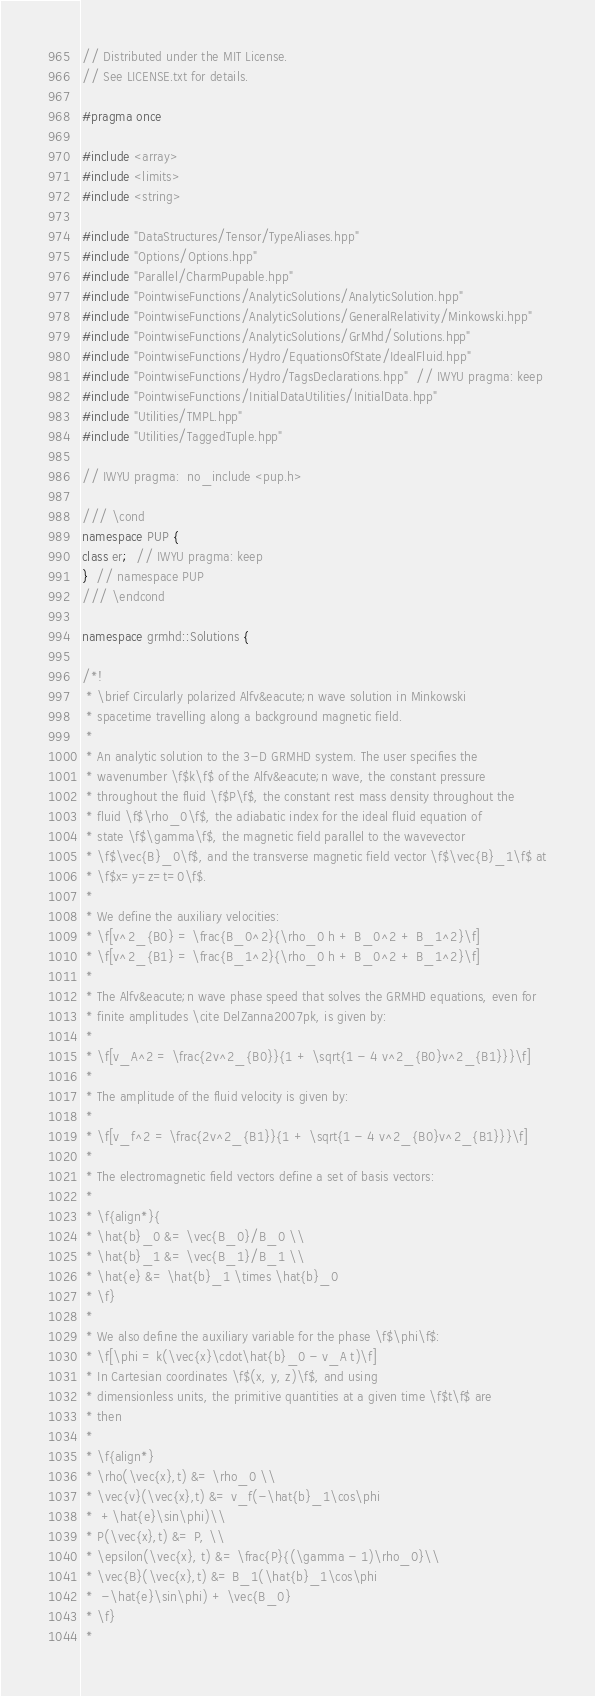Convert code to text. <code><loc_0><loc_0><loc_500><loc_500><_C++_>// Distributed under the MIT License.
// See LICENSE.txt for details.

#pragma once

#include <array>
#include <limits>
#include <string>

#include "DataStructures/Tensor/TypeAliases.hpp"
#include "Options/Options.hpp"
#include "Parallel/CharmPupable.hpp"
#include "PointwiseFunctions/AnalyticSolutions/AnalyticSolution.hpp"
#include "PointwiseFunctions/AnalyticSolutions/GeneralRelativity/Minkowski.hpp"
#include "PointwiseFunctions/AnalyticSolutions/GrMhd/Solutions.hpp"
#include "PointwiseFunctions/Hydro/EquationsOfState/IdealFluid.hpp"
#include "PointwiseFunctions/Hydro/TagsDeclarations.hpp"  // IWYU pragma: keep
#include "PointwiseFunctions/InitialDataUtilities/InitialData.hpp"
#include "Utilities/TMPL.hpp"
#include "Utilities/TaggedTuple.hpp"

// IWYU pragma:  no_include <pup.h>

/// \cond
namespace PUP {
class er;  // IWYU pragma: keep
}  // namespace PUP
/// \endcond

namespace grmhd::Solutions {

/*!
 * \brief Circularly polarized Alfv&eacute;n wave solution in Minkowski
 * spacetime travelling along a background magnetic field.
 *
 * An analytic solution to the 3-D GRMHD system. The user specifies the
 * wavenumber \f$k\f$ of the Alfv&eacute;n wave, the constant pressure
 * throughout the fluid \f$P\f$, the constant rest mass density throughout the
 * fluid \f$\rho_0\f$, the adiabatic index for the ideal fluid equation of
 * state \f$\gamma\f$, the magnetic field parallel to the wavevector
 * \f$\vec{B}_0\f$, and the transverse magnetic field vector \f$\vec{B}_1\f$ at
 * \f$x=y=z=t=0\f$.
 *
 * We define the auxiliary velocities:
 * \f[v^2_{B0} = \frac{B_0^2}{\rho_0 h + B_0^2 + B_1^2}\f]
 * \f[v^2_{B1} = \frac{B_1^2}{\rho_0 h + B_0^2 + B_1^2}\f]
 *
 * The Alfv&eacute;n wave phase speed that solves the GRMHD equations, even for
 * finite amplitudes \cite DelZanna2007pk, is given by:
 *
 * \f[v_A^2 = \frac{2v^2_{B0}}{1 + \sqrt{1 - 4 v^2_{B0}v^2_{B1}}}\f]
 *
 * The amplitude of the fluid velocity is given by:
 *
 * \f[v_f^2 = \frac{2v^2_{B1}}{1 + \sqrt{1 - 4 v^2_{B0}v^2_{B1}}}\f]
 *
 * The electromagnetic field vectors define a set of basis vectors:
 *
 * \f{align*}{
 * \hat{b}_0 &= \vec{B_0}/B_0 \\
 * \hat{b}_1 &= \vec{B_1}/B_1 \\
 * \hat{e} &= \hat{b}_1 \times \hat{b}_0
 * \f}
 *
 * We also define the auxiliary variable for the phase \f$\phi\f$:
 * \f[\phi = k(\vec{x}\cdot\hat{b}_0 - v_A t)\f]
 * In Cartesian coordinates \f$(x, y, z)\f$, and using
 * dimensionless units, the primitive quantities at a given time \f$t\f$ are
 * then
 *
 * \f{align*}
 * \rho(\vec{x},t) &= \rho_0 \\
 * \vec{v}(\vec{x},t) &= v_f(-\hat{b}_1\cos\phi
 *  +\hat{e}\sin\phi)\\
 * P(\vec{x},t) &= P, \\
 * \epsilon(\vec{x}, t) &= \frac{P}{(\gamma - 1)\rho_0}\\
 * \vec{B}(\vec{x},t) &= B_1(\hat{b}_1\cos\phi
 *  -\hat{e}\sin\phi) + \vec{B_0}
 * \f}
 *</code> 